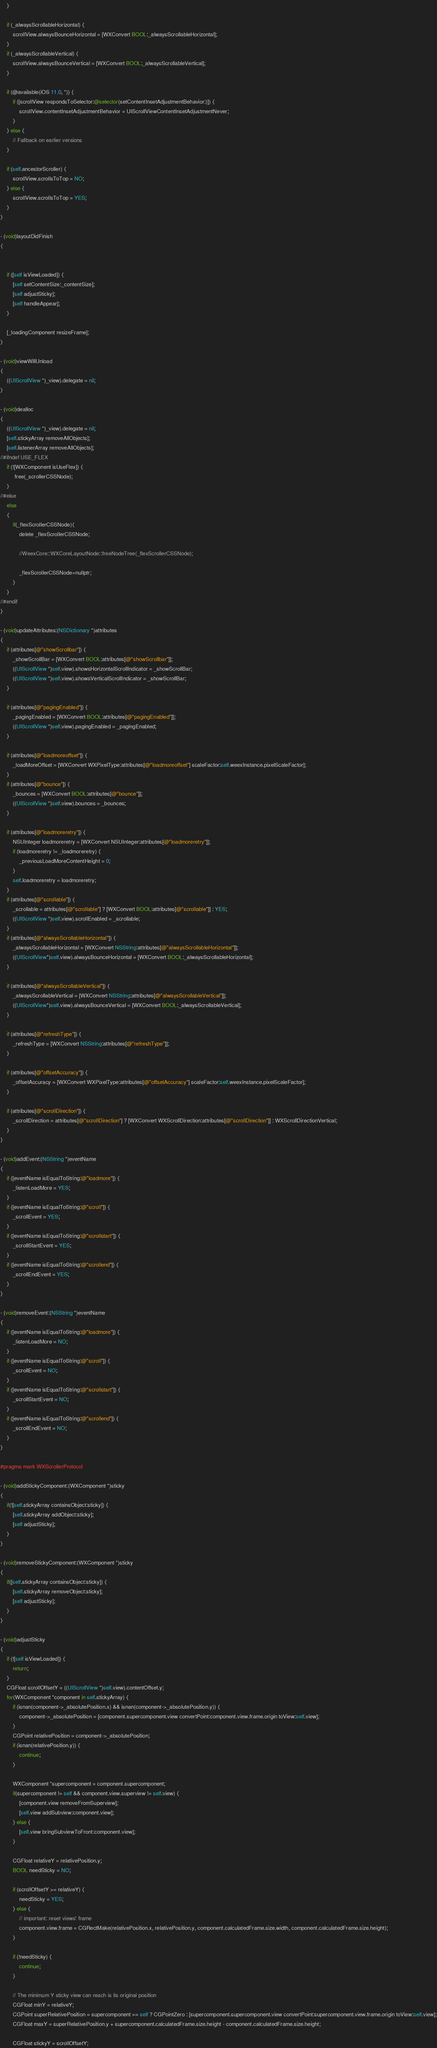Convert code to text. <code><loc_0><loc_0><loc_500><loc_500><_ObjectiveC_>    }
    
    if (_alwaysScrollableHorizontal) {
        scrollView.alwaysBounceHorizontal = [WXConvert BOOL:_alwaysScrollableHorizontal];
    }
    if (_alwaysScrollableVertical) {
        scrollView.alwaysBounceVertical = [WXConvert BOOL:_alwaysScrollableVertical];
    }
    
    if (@available(iOS 11.0, *)) {
        if ([scrollView respondsToSelector:@selector(setContentInsetAdjustmentBehavior:)]) {
            scrollView.contentInsetAdjustmentBehavior = UIScrollViewContentInsetAdjustmentNever;
        }
    } else {
        // Fallback on earlier versions
    }
    
    if (self.ancestorScroller) {
        scrollView.scrollsToTop = NO;
    } else {
        scrollView.scrollsToTop = YES;
    }
}

- (void)layoutDidFinish
{

    
    if ([self isViewLoaded]) {
        [self setContentSize:_contentSize];
        [self adjustSticky];
        [self handleAppear];
    }
    
    [_loadingComponent resizeFrame];
}

- (void)viewWillUnload
{
    ((UIScrollView *)_view).delegate = nil;
}

- (void)dealloc
{
    ((UIScrollView *)_view).delegate = nil;
    [self.stickyArray removeAllObjects];
    [self.listenerArray removeAllObjects];
//#ifndef USE_FLEX
    if (![WXComponent isUseFlex]) {
         free(_scrollerCSSNode);
    }
//#else
    else
    {
        if(_flexScrollerCSSNode){
            delete _flexScrollerCSSNode;
            
            //WeexCore::WXCoreLayoutNode::freeNodeTree(_flexScrollerCSSNode);
            
            _flexScrollerCSSNode=nullptr;
        }
    }
//#endif
}

- (void)updateAttributes:(NSDictionary *)attributes
{
    if (attributes[@"showScrollbar"]) {
        _showScrollBar = [WXConvert BOOL:attributes[@"showScrollbar"]];
        ((UIScrollView *)self.view).showsHorizontalScrollIndicator = _showScrollBar;
        ((UIScrollView *)self.view).showsVerticalScrollIndicator = _showScrollBar;
    }
    
    if (attributes[@"pagingEnabled"]) {
        _pagingEnabled = [WXConvert BOOL:attributes[@"pagingEnabled"]];
        ((UIScrollView *)self.view).pagingEnabled = _pagingEnabled;
    }
    
    if (attributes[@"loadmoreoffset"]) {
        _loadMoreOffset = [WXConvert WXPixelType:attributes[@"loadmoreoffset"] scaleFactor:self.weexInstance.pixelScaleFactor];
    }
    if (attributes[@"bounce"]) {
        _bounces = [WXConvert BOOL:attributes[@"bounce"]];
        ((UIScrollView *)self.view).bounces = _bounces;
    }
    
    if (attributes[@"loadmoreretry"]) {
        NSUInteger loadmoreretry = [WXConvert NSUInteger:attributes[@"loadmoreretry"]];
        if (loadmoreretry != _loadmoreretry) {
            _previousLoadMoreContentHeight = 0;
        }
        self.loadmoreretry = loadmoreretry;
    }
    if (attributes[@"scrollable"]) {
        _scrollable = attributes[@"scrollable"] ? [WXConvert BOOL:attributes[@"scrollable"]] : YES;
        ((UIScrollView *)self.view).scrollEnabled = _scrollable;
    }
    if (attributes[@"alwaysScrollableHorizontal"]) {
        _alwaysScrollableHorizontal = [WXConvert NSString:attributes[@"alwaysScrollableHorizontal"]];
        ((UIScrollView*)self.view).alwaysBounceHorizontal = [WXConvert BOOL:_alwaysScrollableHorizontal];
    }
    
    if (attributes[@"alwaysScrollableVertical"]) {
        _alwaysScrollableVertical = [WXConvert NSString:attributes[@"alwaysScrollableVertical"]];
        ((UIScrollView*)self.view).alwaysBounceVertical = [WXConvert BOOL:_alwaysScrollableVertical];
    }
    
    if (attributes[@"refreshType"]) {
        _refreshType = [WXConvert NSString:attributes[@"refreshType"]];
    }
    
    if (attributes[@"offsetAccuracy"]) {
        _offsetAccuracy = [WXConvert WXPixelType:attributes[@"offsetAccuracy"] scaleFactor:self.weexInstance.pixelScaleFactor];
    }
    
    if (attributes[@"scrollDirection"]) {
        _scrollDirection = attributes[@"scrollDirection"] ? [WXConvert WXScrollDirection:attributes[@"scrollDirection"]] : WXScrollDirectionVertical;
    }
}

- (void)addEvent:(NSString *)eventName
{
    if ([eventName isEqualToString:@"loadmore"]) {
        _listenLoadMore = YES;
    }
    if ([eventName isEqualToString:@"scroll"]) {
        _scrollEvent = YES;
    }
    if ([eventName isEqualToString:@"scrollstart"]) {
        _scrollStartEvent = YES;
    }
    if ([eventName isEqualToString:@"scrollend"]) {
        _scrollEndEvent = YES;
    }
}

- (void)removeEvent:(NSString *)eventName
{
    if ([eventName isEqualToString:@"loadmore"]) {
        _listenLoadMore = NO;
    }
    if ([eventName isEqualToString:@"scroll"]) {
        _scrollEvent = NO;
    }
    if ([eventName isEqualToString:@"scrollstart"]) {
        _scrollStartEvent = NO;
    }
    if ([eventName isEqualToString:@"scrollend"]) {
        _scrollEndEvent = NO;
    }
}

#pragma mark WXScrollerProtocol

- (void)addStickyComponent:(WXComponent *)sticky
{
    if(![self.stickyArray containsObject:sticky]) {
        [self.stickyArray addObject:sticky];
        [self adjustSticky];
    }
}

- (void)removeStickyComponent:(WXComponent *)sticky
{
    if([self.stickyArray containsObject:sticky]) {
        [self.stickyArray removeObject:sticky];
        [self adjustSticky];
    }
}

- (void)adjustSticky
{
    if (![self isViewLoaded]) {
        return;
    }
    CGFloat scrollOffsetY = ((UIScrollView *)self.view).contentOffset.y;
    for(WXComponent *component in self.stickyArray) {
        if (isnan(component->_absolutePosition.x) && isnan(component->_absolutePosition.y)) {
            component->_absolutePosition = [component.supercomponent.view convertPoint:component.view.frame.origin toView:self.view];
        }
        CGPoint relativePosition = component->_absolutePosition;
        if (isnan(relativePosition.y)) {
            continue;
        }
        
        WXComponent *supercomponent = component.supercomponent;
        if(supercomponent != self && component.view.superview != self.view) {
            [component.view removeFromSuperview];
            [self.view addSubview:component.view];
        } else {
            [self.view bringSubviewToFront:component.view];
        }
        
        CGFloat relativeY = relativePosition.y;
        BOOL needSticky = NO;
        
        if (scrollOffsetY >= relativeY) {
            needSticky = YES;
        } else {
            // important: reset views' frame
            component.view.frame = CGRectMake(relativePosition.x, relativePosition.y, component.calculatedFrame.size.width, component.calculatedFrame.size.height);
        }
        
        if (!needSticky) {
            continue;
        }
        
        // The minimum Y sticky view can reach is its original position
        CGFloat minY = relativeY;
        CGPoint superRelativePosition = supercomponent == self ? CGPointZero : [supercomponent.supercomponent.view convertPoint:supercomponent.view.frame.origin toView:self.view];
        CGFloat maxY = superRelativePosition.y + supercomponent.calculatedFrame.size.height - component.calculatedFrame.size.height;
        
        CGFloat stickyY = scrollOffsetY;</code> 